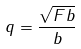<formula> <loc_0><loc_0><loc_500><loc_500>q = \frac { \sqrt { F b } } { b }</formula> 